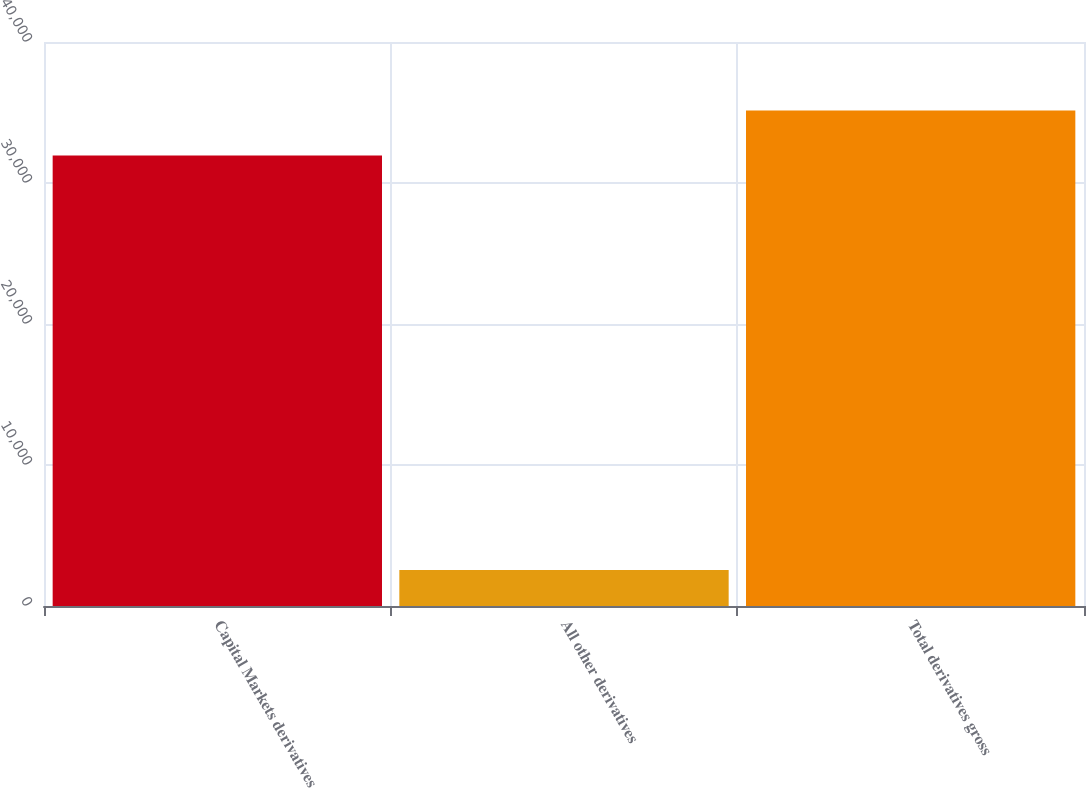<chart> <loc_0><loc_0><loc_500><loc_500><bar_chart><fcel>Capital Markets derivatives<fcel>All other derivatives<fcel>Total derivatives gross<nl><fcel>31951<fcel>2554<fcel>35146.1<nl></chart> 